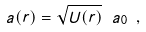<formula> <loc_0><loc_0><loc_500><loc_500>a ( r ) = \sqrt { U ( r ) } \ a _ { 0 } \ ,</formula> 